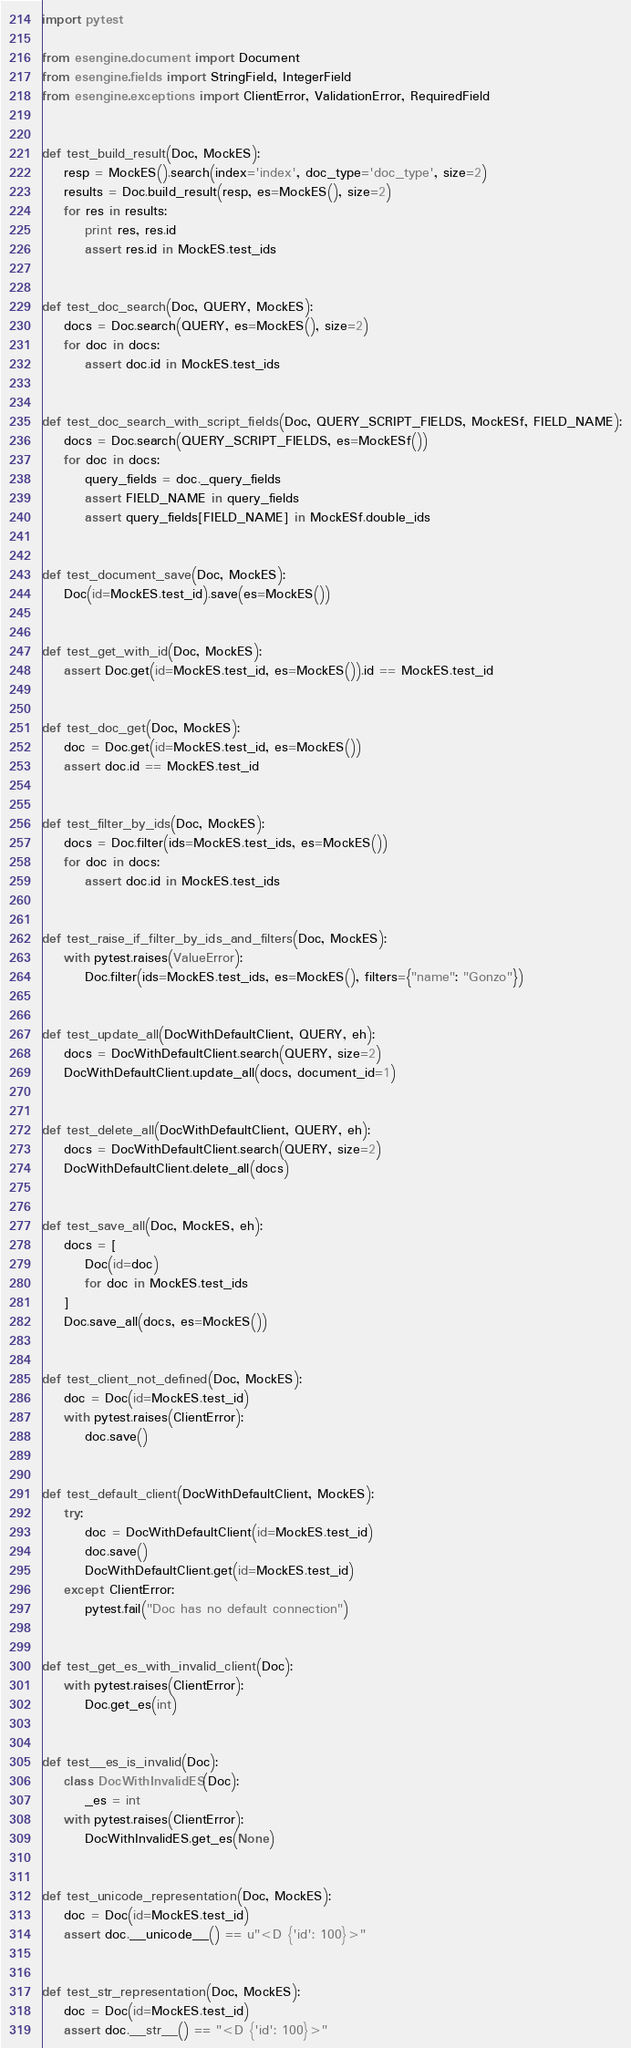<code> <loc_0><loc_0><loc_500><loc_500><_Python_>import pytest

from esengine.document import Document
from esengine.fields import StringField, IntegerField
from esengine.exceptions import ClientError, ValidationError, RequiredField


def test_build_result(Doc, MockES):
    resp = MockES().search(index='index', doc_type='doc_type', size=2)
    results = Doc.build_result(resp, es=MockES(), size=2)
    for res in results:
        print res, res.id
        assert res.id in MockES.test_ids


def test_doc_search(Doc, QUERY, MockES):
    docs = Doc.search(QUERY, es=MockES(), size=2)
    for doc in docs:
        assert doc.id in MockES.test_ids


def test_doc_search_with_script_fields(Doc, QUERY_SCRIPT_FIELDS, MockESf, FIELD_NAME):
    docs = Doc.search(QUERY_SCRIPT_FIELDS, es=MockESf())
    for doc in docs:
        query_fields = doc._query_fields
        assert FIELD_NAME in query_fields
        assert query_fields[FIELD_NAME] in MockESf.double_ids


def test_document_save(Doc, MockES):
    Doc(id=MockES.test_id).save(es=MockES())


def test_get_with_id(Doc, MockES):
    assert Doc.get(id=MockES.test_id, es=MockES()).id == MockES.test_id


def test_doc_get(Doc, MockES):
    doc = Doc.get(id=MockES.test_id, es=MockES())
    assert doc.id == MockES.test_id


def test_filter_by_ids(Doc, MockES):
    docs = Doc.filter(ids=MockES.test_ids, es=MockES())
    for doc in docs:
        assert doc.id in MockES.test_ids


def test_raise_if_filter_by_ids_and_filters(Doc, MockES):
    with pytest.raises(ValueError):
        Doc.filter(ids=MockES.test_ids, es=MockES(), filters={"name": "Gonzo"})


def test_update_all(DocWithDefaultClient, QUERY, eh):
    docs = DocWithDefaultClient.search(QUERY, size=2)
    DocWithDefaultClient.update_all(docs, document_id=1)


def test_delete_all(DocWithDefaultClient, QUERY, eh):
    docs = DocWithDefaultClient.search(QUERY, size=2)
    DocWithDefaultClient.delete_all(docs)


def test_save_all(Doc, MockES, eh):
    docs = [
        Doc(id=doc)
        for doc in MockES.test_ids
    ]
    Doc.save_all(docs, es=MockES())


def test_client_not_defined(Doc, MockES):
    doc = Doc(id=MockES.test_id)
    with pytest.raises(ClientError):
        doc.save()


def test_default_client(DocWithDefaultClient, MockES):
    try:
        doc = DocWithDefaultClient(id=MockES.test_id)
        doc.save()
        DocWithDefaultClient.get(id=MockES.test_id)
    except ClientError:
        pytest.fail("Doc has no default connection")


def test_get_es_with_invalid_client(Doc):
    with pytest.raises(ClientError):
        Doc.get_es(int)


def test__es_is_invalid(Doc):
    class DocWithInvalidES(Doc):
        _es = int
    with pytest.raises(ClientError):
        DocWithInvalidES.get_es(None)


def test_unicode_representation(Doc, MockES):
    doc = Doc(id=MockES.test_id)
    assert doc.__unicode__() == u"<D {'id': 100}>"


def test_str_representation(Doc, MockES):
    doc = Doc(id=MockES.test_id)
    assert doc.__str__() == "<D {'id': 100}>"

</code> 